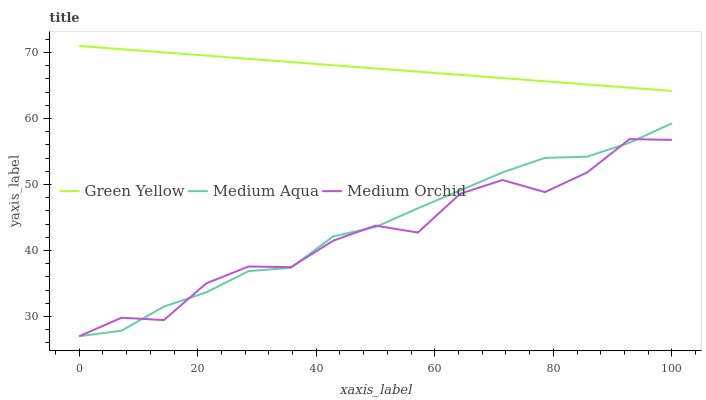Does Medium Aqua have the minimum area under the curve?
Answer yes or no. No. Does Medium Aqua have the maximum area under the curve?
Answer yes or no. No. Is Medium Aqua the smoothest?
Answer yes or no. No. Is Medium Aqua the roughest?
Answer yes or no. No. Does Green Yellow have the lowest value?
Answer yes or no. No. Does Medium Aqua have the highest value?
Answer yes or no. No. Is Medium Aqua less than Green Yellow?
Answer yes or no. Yes. Is Green Yellow greater than Medium Aqua?
Answer yes or no. Yes. Does Medium Aqua intersect Green Yellow?
Answer yes or no. No. 